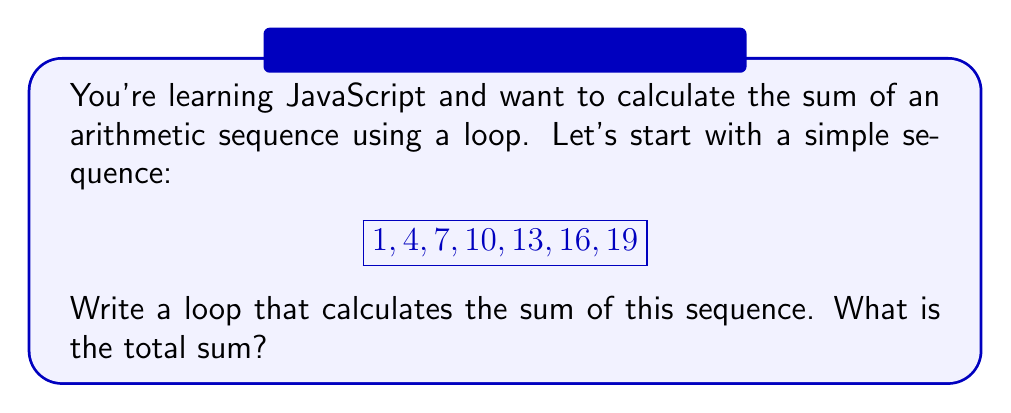Teach me how to tackle this problem. Let's break this down step-by-step:

1) First, let's identify the components of this arithmetic sequence:
   - First term (a): $a = 1$
   - Common difference (d): $d = 3$
   - Number of terms (n): $n = 7$

2) In JavaScript, we can use a for loop to calculate the sum. Here's how we'd structure it:

   ```javascript
   let sum = 0;
   for (let i = 0; i < 7; i++) {
     let term = 1 + (3 * i);
     sum += term;
   }
   ```

3) Let's go through each iteration:
   - i = 0: term = 1 + (3 * 0) = 1,  sum = 1
   - i = 1: term = 1 + (3 * 1) = 4,  sum = 1 + 4 = 5
   - i = 2: term = 1 + (3 * 2) = 7,  sum = 5 + 7 = 12
   - i = 3: term = 1 + (3 * 3) = 10, sum = 12 + 10 = 22
   - i = 4: term = 1 + (3 * 4) = 13, sum = 22 + 13 = 35
   - i = 5: term = 1 + (3 * 5) = 16, sum = 35 + 16 = 51
   - i = 6: term = 1 + (3 * 6) = 19, sum = 51 + 19 = 70

4) We can verify this result using the arithmetic sequence sum formula:
   
   $$S_n = \frac{n}{2}(a_1 + a_n) = \frac{7}{2}(1 + 19) = \frac{7}{2}(20) = 70$$

Therefore, the sum of the sequence is 70.
Answer: 70 